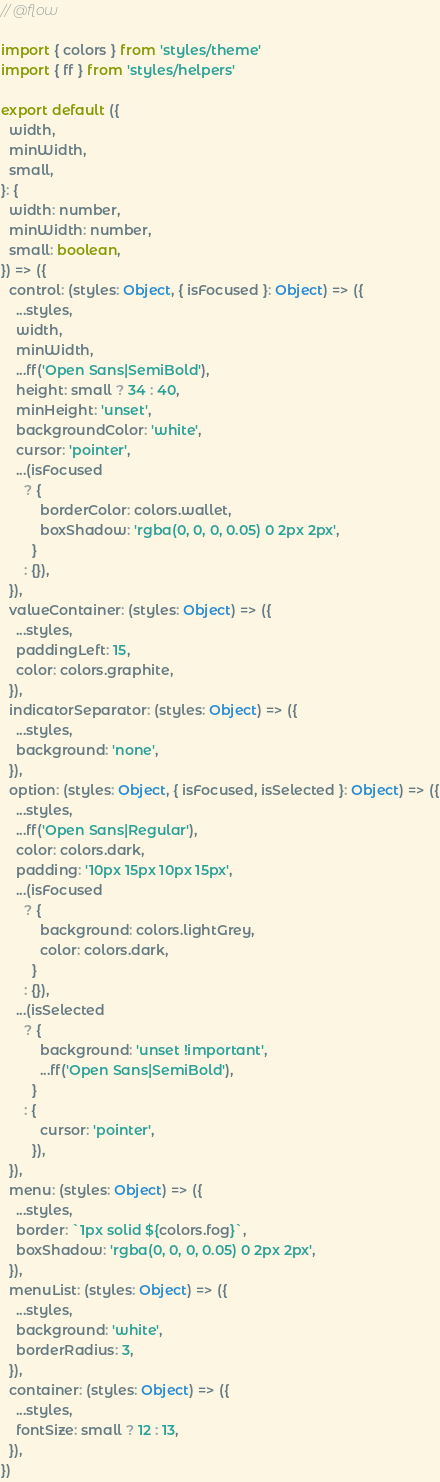Convert code to text. <code><loc_0><loc_0><loc_500><loc_500><_JavaScript_>// @flow

import { colors } from 'styles/theme'
import { ff } from 'styles/helpers'

export default ({
  width,
  minWidth,
  small,
}: {
  width: number,
  minWidth: number,
  small: boolean,
}) => ({
  control: (styles: Object, { isFocused }: Object) => ({
    ...styles,
    width,
    minWidth,
    ...ff('Open Sans|SemiBold'),
    height: small ? 34 : 40,
    minHeight: 'unset',
    backgroundColor: 'white',
    cursor: 'pointer',
    ...(isFocused
      ? {
          borderColor: colors.wallet,
          boxShadow: 'rgba(0, 0, 0, 0.05) 0 2px 2px',
        }
      : {}),
  }),
  valueContainer: (styles: Object) => ({
    ...styles,
    paddingLeft: 15,
    color: colors.graphite,
  }),
  indicatorSeparator: (styles: Object) => ({
    ...styles,
    background: 'none',
  }),
  option: (styles: Object, { isFocused, isSelected }: Object) => ({
    ...styles,
    ...ff('Open Sans|Regular'),
    color: colors.dark,
    padding: '10px 15px 10px 15px',
    ...(isFocused
      ? {
          background: colors.lightGrey,
          color: colors.dark,
        }
      : {}),
    ...(isSelected
      ? {
          background: 'unset !important',
          ...ff('Open Sans|SemiBold'),
        }
      : {
          cursor: 'pointer',
        }),
  }),
  menu: (styles: Object) => ({
    ...styles,
    border: `1px solid ${colors.fog}`,
    boxShadow: 'rgba(0, 0, 0, 0.05) 0 2px 2px',
  }),
  menuList: (styles: Object) => ({
    ...styles,
    background: 'white',
    borderRadius: 3,
  }),
  container: (styles: Object) => ({
    ...styles,
    fontSize: small ? 12 : 13,
  }),
})
</code> 